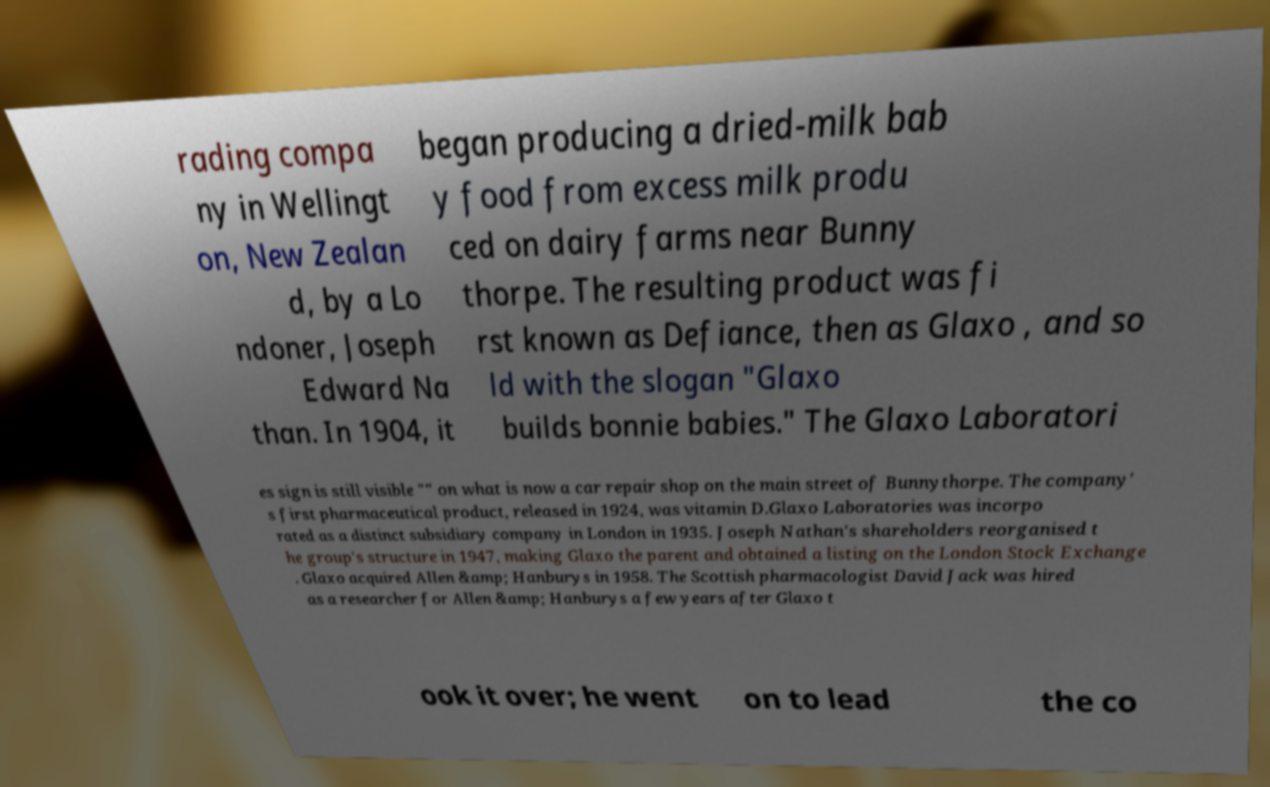Please identify and transcribe the text found in this image. rading compa ny in Wellingt on, New Zealan d, by a Lo ndoner, Joseph Edward Na than. In 1904, it began producing a dried-milk bab y food from excess milk produ ced on dairy farms near Bunny thorpe. The resulting product was fi rst known as Defiance, then as Glaxo , and so ld with the slogan "Glaxo builds bonnie babies." The Glaxo Laboratori es sign is still visible "" on what is now a car repair shop on the main street of Bunnythorpe. The company' s first pharmaceutical product, released in 1924, was vitamin D.Glaxo Laboratories was incorpo rated as a distinct subsidiary company in London in 1935. Joseph Nathan's shareholders reorganised t he group's structure in 1947, making Glaxo the parent and obtained a listing on the London Stock Exchange . Glaxo acquired Allen &amp; Hanburys in 1958. The Scottish pharmacologist David Jack was hired as a researcher for Allen &amp; Hanburys a few years after Glaxo t ook it over; he went on to lead the co 